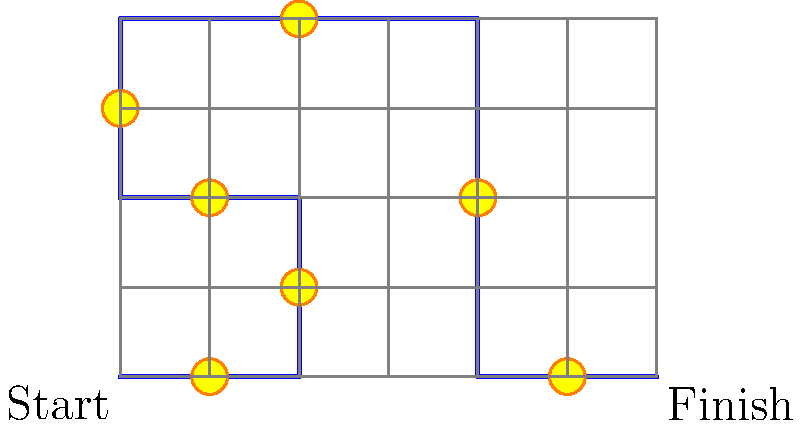In this classic Sonic-style level, you need to navigate through the maze-like path from start to finish. Each yellow circle represents a ring. How many rings can Sonic collect if he follows the optimal path through the maze? To solve this problem, we need to count the number of rings (yellow circles) that intersect with the blue path from start to finish. Let's follow the path step by step:

1. Starting at (0,0), we move right to (2,0):
   - We collect 1 ring at (1,0)

2. Moving up to (2,2):
   - We collect 1 ring at (2,1)

3. Moving left to (0,2):
   - We collect 1 ring at (1,2)

4. Moving up to (0,4):
   - We collect 1 ring at (0,3)

5. Moving right to (4,4):
   - We collect 1 ring at (2,4)

6. Moving down to (4,0):
   - We collect 1 ring at (4,2)

7. Moving right to the finish at (6,0):
   - We collect 1 ring at (5,0)

In total, Sonic can collect 7 rings along the optimal path through the maze.
Answer: 7 rings 